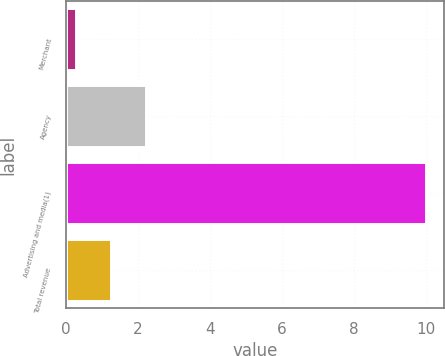Convert chart. <chart><loc_0><loc_0><loc_500><loc_500><bar_chart><fcel>Merchant<fcel>Agency<fcel>Advertising and media(1)<fcel>Total revenue<nl><fcel>0.29<fcel>2.23<fcel>10<fcel>1.26<nl></chart> 